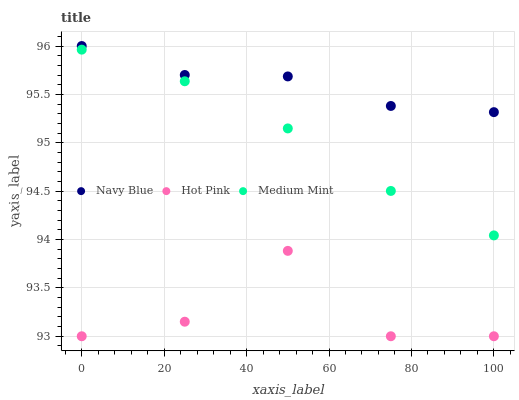Does Hot Pink have the minimum area under the curve?
Answer yes or no. Yes. Does Navy Blue have the maximum area under the curve?
Answer yes or no. Yes. Does Navy Blue have the minimum area under the curve?
Answer yes or no. No. Does Hot Pink have the maximum area under the curve?
Answer yes or no. No. Is Medium Mint the smoothest?
Answer yes or no. Yes. Is Hot Pink the roughest?
Answer yes or no. Yes. Is Navy Blue the smoothest?
Answer yes or no. No. Is Navy Blue the roughest?
Answer yes or no. No. Does Hot Pink have the lowest value?
Answer yes or no. Yes. Does Navy Blue have the lowest value?
Answer yes or no. No. Does Navy Blue have the highest value?
Answer yes or no. Yes. Does Hot Pink have the highest value?
Answer yes or no. No. Is Hot Pink less than Medium Mint?
Answer yes or no. Yes. Is Navy Blue greater than Hot Pink?
Answer yes or no. Yes. Does Hot Pink intersect Medium Mint?
Answer yes or no. No. 